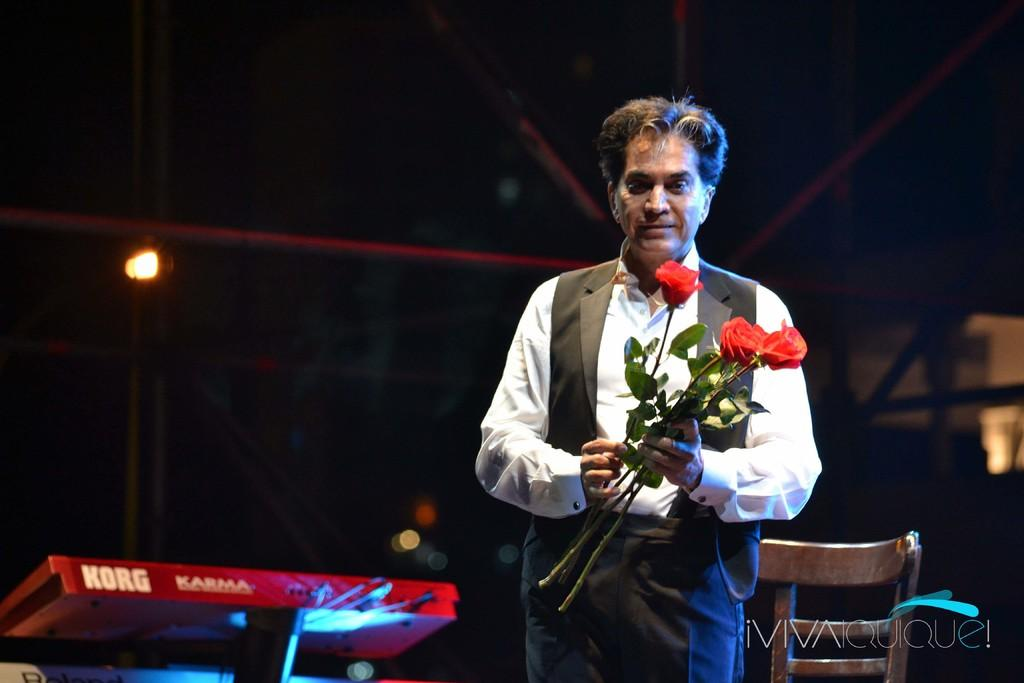What is the main subject of the image? The main subject of the image is a man. What is the man doing in the image? The man is standing in the image. What is the man holding in his hand? The man is holding roses in his hand. What can be seen in the background of the image? There is a chair in the background of the image. What is the source of light in the image? There is a light in the image. How many flags are present in the image? There are no flags present in the image. What type of lunch is the man eating in the image? There is no lunch visible in the image; the man is holding roses. 